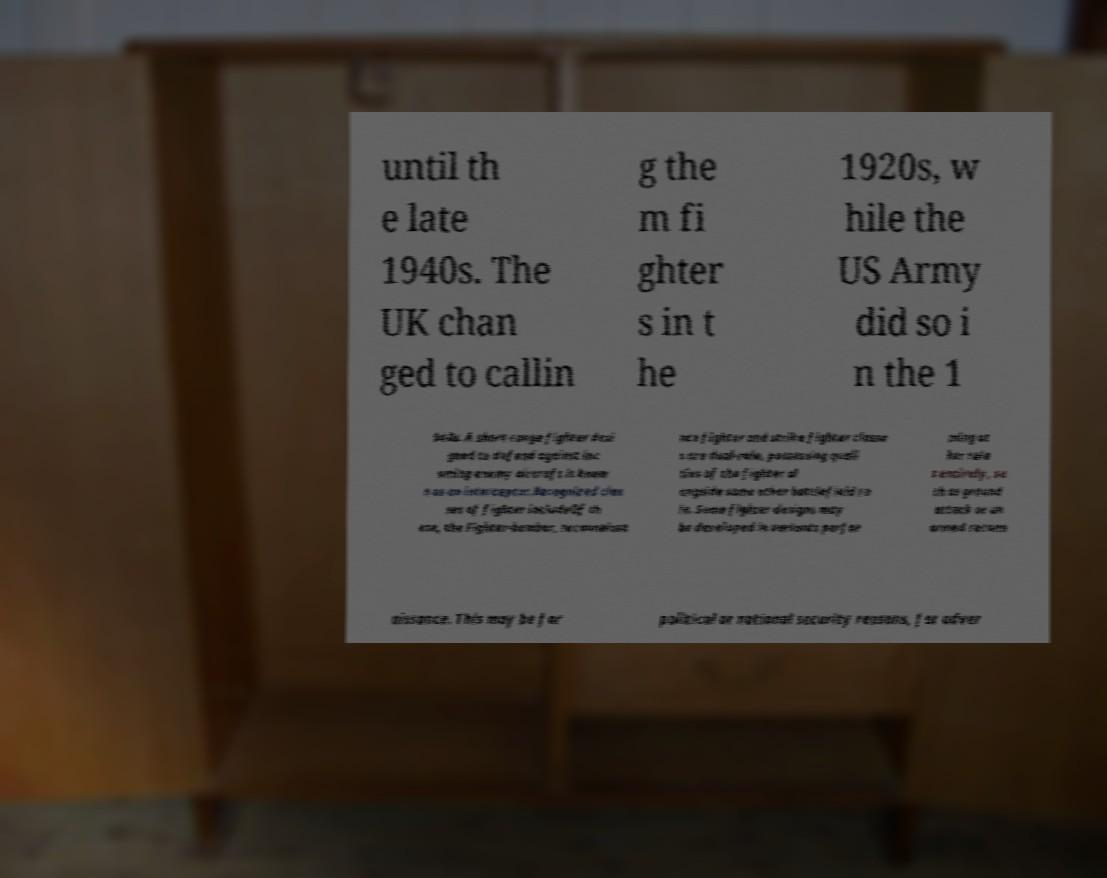Could you extract and type out the text from this image? until th e late 1940s. The UK chan ged to callin g the m fi ghter s in t he 1920s, w hile the US Army did so i n the 1 940s. A short-range fighter desi gned to defend against inc oming enemy aircraft is know n as an interceptor.Recognized clas ses of fighter includeOf th ese, the Fighter-bomber, reconnaissa nce fighter and strike fighter classe s are dual-role, possessing quali ties of the fighter al ongside some other battlefield ro le. Some fighter designs may be developed in variants perfor ming ot her role s entirely, su ch as ground attack or un armed reconn aissance. This may be for political or national security reasons, for adver 